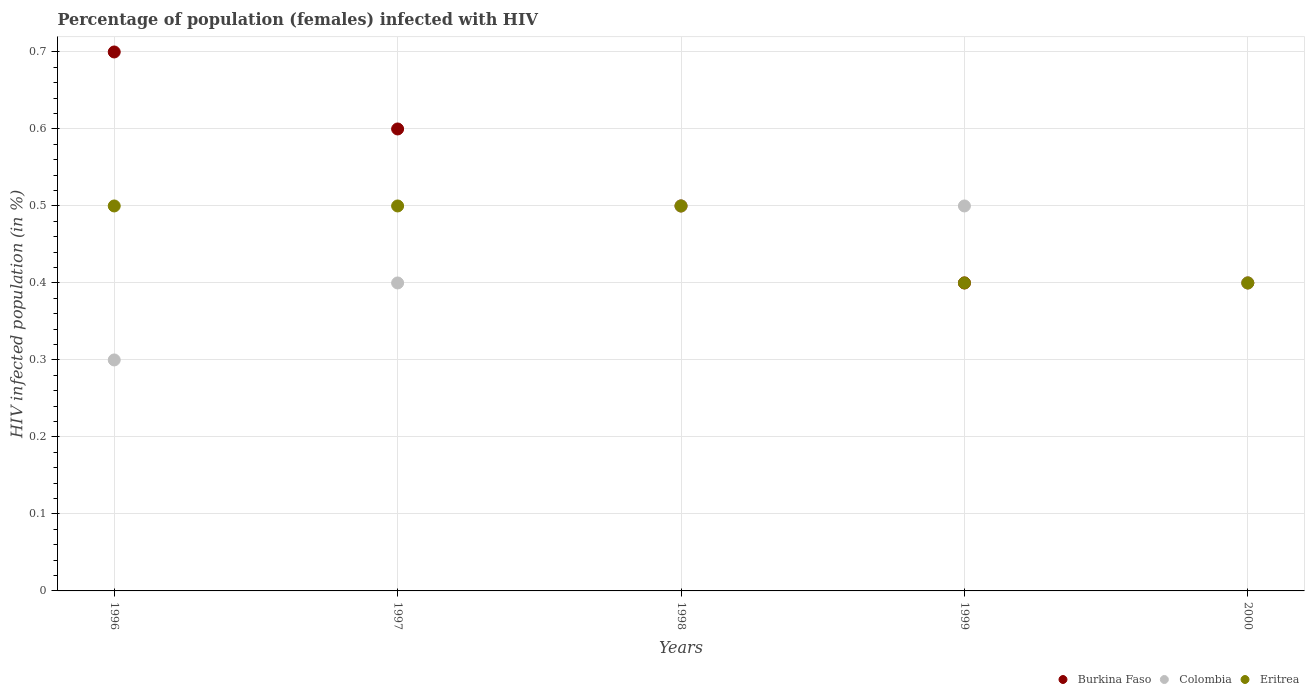How many different coloured dotlines are there?
Keep it short and to the point. 3. Is the number of dotlines equal to the number of legend labels?
Give a very brief answer. Yes. Across all years, what is the maximum percentage of HIV infected female population in Burkina Faso?
Ensure brevity in your answer.  0.7. Across all years, what is the minimum percentage of HIV infected female population in Eritrea?
Make the answer very short. 0.4. In which year was the percentage of HIV infected female population in Burkina Faso minimum?
Keep it short and to the point. 1999. What is the total percentage of HIV infected female population in Burkina Faso in the graph?
Give a very brief answer. 2.6. What is the average percentage of HIV infected female population in Eritrea per year?
Give a very brief answer. 0.46. In the year 1998, what is the difference between the percentage of HIV infected female population in Colombia and percentage of HIV infected female population in Eritrea?
Your response must be concise. 0. What is the ratio of the percentage of HIV infected female population in Burkina Faso in 1998 to that in 1999?
Keep it short and to the point. 1.25. What is the difference between the highest and the second highest percentage of HIV infected female population in Colombia?
Ensure brevity in your answer.  0. What is the difference between the highest and the lowest percentage of HIV infected female population in Colombia?
Make the answer very short. 0.2. In how many years, is the percentage of HIV infected female population in Burkina Faso greater than the average percentage of HIV infected female population in Burkina Faso taken over all years?
Keep it short and to the point. 2. Is it the case that in every year, the sum of the percentage of HIV infected female population in Colombia and percentage of HIV infected female population in Eritrea  is greater than the percentage of HIV infected female population in Burkina Faso?
Your response must be concise. Yes. Does the percentage of HIV infected female population in Colombia monotonically increase over the years?
Offer a terse response. No. Is the percentage of HIV infected female population in Colombia strictly greater than the percentage of HIV infected female population in Eritrea over the years?
Ensure brevity in your answer.  No. Is the percentage of HIV infected female population in Burkina Faso strictly less than the percentage of HIV infected female population in Eritrea over the years?
Offer a very short reply. No. How many dotlines are there?
Provide a succinct answer. 3. How many years are there in the graph?
Provide a short and direct response. 5. What is the difference between two consecutive major ticks on the Y-axis?
Make the answer very short. 0.1. Are the values on the major ticks of Y-axis written in scientific E-notation?
Offer a very short reply. No. Does the graph contain grids?
Offer a terse response. Yes. How are the legend labels stacked?
Your answer should be compact. Horizontal. What is the title of the graph?
Give a very brief answer. Percentage of population (females) infected with HIV. Does "Burkina Faso" appear as one of the legend labels in the graph?
Give a very brief answer. Yes. What is the label or title of the X-axis?
Offer a very short reply. Years. What is the label or title of the Y-axis?
Your response must be concise. HIV infected population (in %). What is the HIV infected population (in %) in Burkina Faso in 1996?
Offer a terse response. 0.7. What is the HIV infected population (in %) of Eritrea in 1996?
Provide a succinct answer. 0.5. What is the HIV infected population (in %) of Burkina Faso in 1997?
Make the answer very short. 0.6. What is the HIV infected population (in %) of Eritrea in 1997?
Your answer should be compact. 0.5. What is the HIV infected population (in %) of Burkina Faso in 1998?
Ensure brevity in your answer.  0.5. What is the HIV infected population (in %) of Colombia in 1998?
Ensure brevity in your answer.  0.5. What is the HIV infected population (in %) of Burkina Faso in 2000?
Keep it short and to the point. 0.4. What is the HIV infected population (in %) of Colombia in 2000?
Provide a short and direct response. 0.4. Across all years, what is the maximum HIV infected population (in %) in Eritrea?
Your response must be concise. 0.5. Across all years, what is the minimum HIV infected population (in %) of Burkina Faso?
Give a very brief answer. 0.4. Across all years, what is the minimum HIV infected population (in %) of Colombia?
Offer a terse response. 0.3. What is the difference between the HIV infected population (in %) of Burkina Faso in 1996 and that in 1997?
Keep it short and to the point. 0.1. What is the difference between the HIV infected population (in %) of Eritrea in 1996 and that in 1997?
Provide a short and direct response. 0. What is the difference between the HIV infected population (in %) in Burkina Faso in 1996 and that in 1998?
Provide a succinct answer. 0.2. What is the difference between the HIV infected population (in %) of Colombia in 1996 and that in 1998?
Provide a short and direct response. -0.2. What is the difference between the HIV infected population (in %) in Burkina Faso in 1996 and that in 1999?
Provide a succinct answer. 0.3. What is the difference between the HIV infected population (in %) in Colombia in 1996 and that in 1999?
Your answer should be very brief. -0.2. What is the difference between the HIV infected population (in %) in Burkina Faso in 1996 and that in 2000?
Your response must be concise. 0.3. What is the difference between the HIV infected population (in %) of Colombia in 1996 and that in 2000?
Your response must be concise. -0.1. What is the difference between the HIV infected population (in %) in Colombia in 1997 and that in 1998?
Your answer should be very brief. -0.1. What is the difference between the HIV infected population (in %) in Eritrea in 1997 and that in 1999?
Offer a terse response. 0.1. What is the difference between the HIV infected population (in %) of Colombia in 1997 and that in 2000?
Your answer should be compact. 0. What is the difference between the HIV infected population (in %) in Eritrea in 1997 and that in 2000?
Make the answer very short. 0.1. What is the difference between the HIV infected population (in %) in Eritrea in 1998 and that in 1999?
Your answer should be compact. 0.1. What is the difference between the HIV infected population (in %) of Colombia in 1998 and that in 2000?
Keep it short and to the point. 0.1. What is the difference between the HIV infected population (in %) of Burkina Faso in 1999 and that in 2000?
Offer a very short reply. 0. What is the difference between the HIV infected population (in %) of Colombia in 1999 and that in 2000?
Ensure brevity in your answer.  0.1. What is the difference between the HIV infected population (in %) of Eritrea in 1999 and that in 2000?
Offer a terse response. 0. What is the difference between the HIV infected population (in %) of Burkina Faso in 1996 and the HIV infected population (in %) of Eritrea in 1997?
Your answer should be compact. 0.2. What is the difference between the HIV infected population (in %) of Colombia in 1996 and the HIV infected population (in %) of Eritrea in 1997?
Provide a short and direct response. -0.2. What is the difference between the HIV infected population (in %) in Burkina Faso in 1996 and the HIV infected population (in %) in Colombia in 1998?
Make the answer very short. 0.2. What is the difference between the HIV infected population (in %) of Burkina Faso in 1996 and the HIV infected population (in %) of Eritrea in 2000?
Your response must be concise. 0.3. What is the difference between the HIV infected population (in %) in Burkina Faso in 1997 and the HIV infected population (in %) in Colombia in 1998?
Your answer should be very brief. 0.1. What is the difference between the HIV infected population (in %) of Burkina Faso in 1997 and the HIV infected population (in %) of Eritrea in 1998?
Provide a succinct answer. 0.1. What is the difference between the HIV infected population (in %) in Colombia in 1997 and the HIV infected population (in %) in Eritrea in 1998?
Offer a terse response. -0.1. What is the difference between the HIV infected population (in %) in Burkina Faso in 1997 and the HIV infected population (in %) in Colombia in 1999?
Your answer should be very brief. 0.1. What is the difference between the HIV infected population (in %) of Burkina Faso in 1997 and the HIV infected population (in %) of Eritrea in 1999?
Your response must be concise. 0.2. What is the difference between the HIV infected population (in %) of Burkina Faso in 1997 and the HIV infected population (in %) of Eritrea in 2000?
Keep it short and to the point. 0.2. What is the difference between the HIV infected population (in %) of Burkina Faso in 1998 and the HIV infected population (in %) of Colombia in 1999?
Offer a very short reply. 0. What is the difference between the HIV infected population (in %) in Colombia in 1998 and the HIV infected population (in %) in Eritrea in 1999?
Ensure brevity in your answer.  0.1. What is the difference between the HIV infected population (in %) in Colombia in 1998 and the HIV infected population (in %) in Eritrea in 2000?
Provide a short and direct response. 0.1. What is the difference between the HIV infected population (in %) of Burkina Faso in 1999 and the HIV infected population (in %) of Colombia in 2000?
Keep it short and to the point. 0. What is the difference between the HIV infected population (in %) of Burkina Faso in 1999 and the HIV infected population (in %) of Eritrea in 2000?
Make the answer very short. 0. What is the average HIV infected population (in %) of Burkina Faso per year?
Offer a very short reply. 0.52. What is the average HIV infected population (in %) of Colombia per year?
Provide a short and direct response. 0.42. What is the average HIV infected population (in %) of Eritrea per year?
Make the answer very short. 0.46. In the year 1996, what is the difference between the HIV infected population (in %) in Burkina Faso and HIV infected population (in %) in Colombia?
Offer a terse response. 0.4. In the year 1996, what is the difference between the HIV infected population (in %) of Colombia and HIV infected population (in %) of Eritrea?
Your answer should be very brief. -0.2. In the year 1997, what is the difference between the HIV infected population (in %) in Burkina Faso and HIV infected population (in %) in Colombia?
Offer a terse response. 0.2. In the year 1998, what is the difference between the HIV infected population (in %) in Burkina Faso and HIV infected population (in %) in Colombia?
Offer a terse response. 0. In the year 1999, what is the difference between the HIV infected population (in %) of Burkina Faso and HIV infected population (in %) of Colombia?
Ensure brevity in your answer.  -0.1. In the year 1999, what is the difference between the HIV infected population (in %) of Colombia and HIV infected population (in %) of Eritrea?
Offer a very short reply. 0.1. In the year 2000, what is the difference between the HIV infected population (in %) in Burkina Faso and HIV infected population (in %) in Colombia?
Provide a succinct answer. 0. In the year 2000, what is the difference between the HIV infected population (in %) of Colombia and HIV infected population (in %) of Eritrea?
Your answer should be very brief. 0. What is the ratio of the HIV infected population (in %) of Eritrea in 1996 to that in 1997?
Offer a very short reply. 1. What is the ratio of the HIV infected population (in %) in Eritrea in 1996 to that in 1998?
Your answer should be very brief. 1. What is the ratio of the HIV infected population (in %) of Burkina Faso in 1996 to that in 2000?
Your answer should be compact. 1.75. What is the ratio of the HIV infected population (in %) of Eritrea in 1996 to that in 2000?
Ensure brevity in your answer.  1.25. What is the ratio of the HIV infected population (in %) in Burkina Faso in 1997 to that in 1999?
Your answer should be compact. 1.5. What is the ratio of the HIV infected population (in %) of Eritrea in 1997 to that in 1999?
Your response must be concise. 1.25. What is the ratio of the HIV infected population (in %) of Burkina Faso in 1997 to that in 2000?
Your answer should be compact. 1.5. What is the ratio of the HIV infected population (in %) in Colombia in 1997 to that in 2000?
Offer a terse response. 1. What is the ratio of the HIV infected population (in %) in Burkina Faso in 1998 to that in 1999?
Your answer should be very brief. 1.25. What is the ratio of the HIV infected population (in %) of Eritrea in 1998 to that in 1999?
Offer a very short reply. 1.25. What is the ratio of the HIV infected population (in %) in Burkina Faso in 1998 to that in 2000?
Provide a short and direct response. 1.25. What is the ratio of the HIV infected population (in %) in Eritrea in 1998 to that in 2000?
Your answer should be compact. 1.25. What is the ratio of the HIV infected population (in %) of Burkina Faso in 1999 to that in 2000?
Provide a short and direct response. 1. What is the ratio of the HIV infected population (in %) in Eritrea in 1999 to that in 2000?
Your answer should be compact. 1. What is the difference between the highest and the second highest HIV infected population (in %) in Burkina Faso?
Give a very brief answer. 0.1. What is the difference between the highest and the second highest HIV infected population (in %) of Colombia?
Your response must be concise. 0. What is the difference between the highest and the lowest HIV infected population (in %) of Colombia?
Provide a short and direct response. 0.2. What is the difference between the highest and the lowest HIV infected population (in %) of Eritrea?
Ensure brevity in your answer.  0.1. 